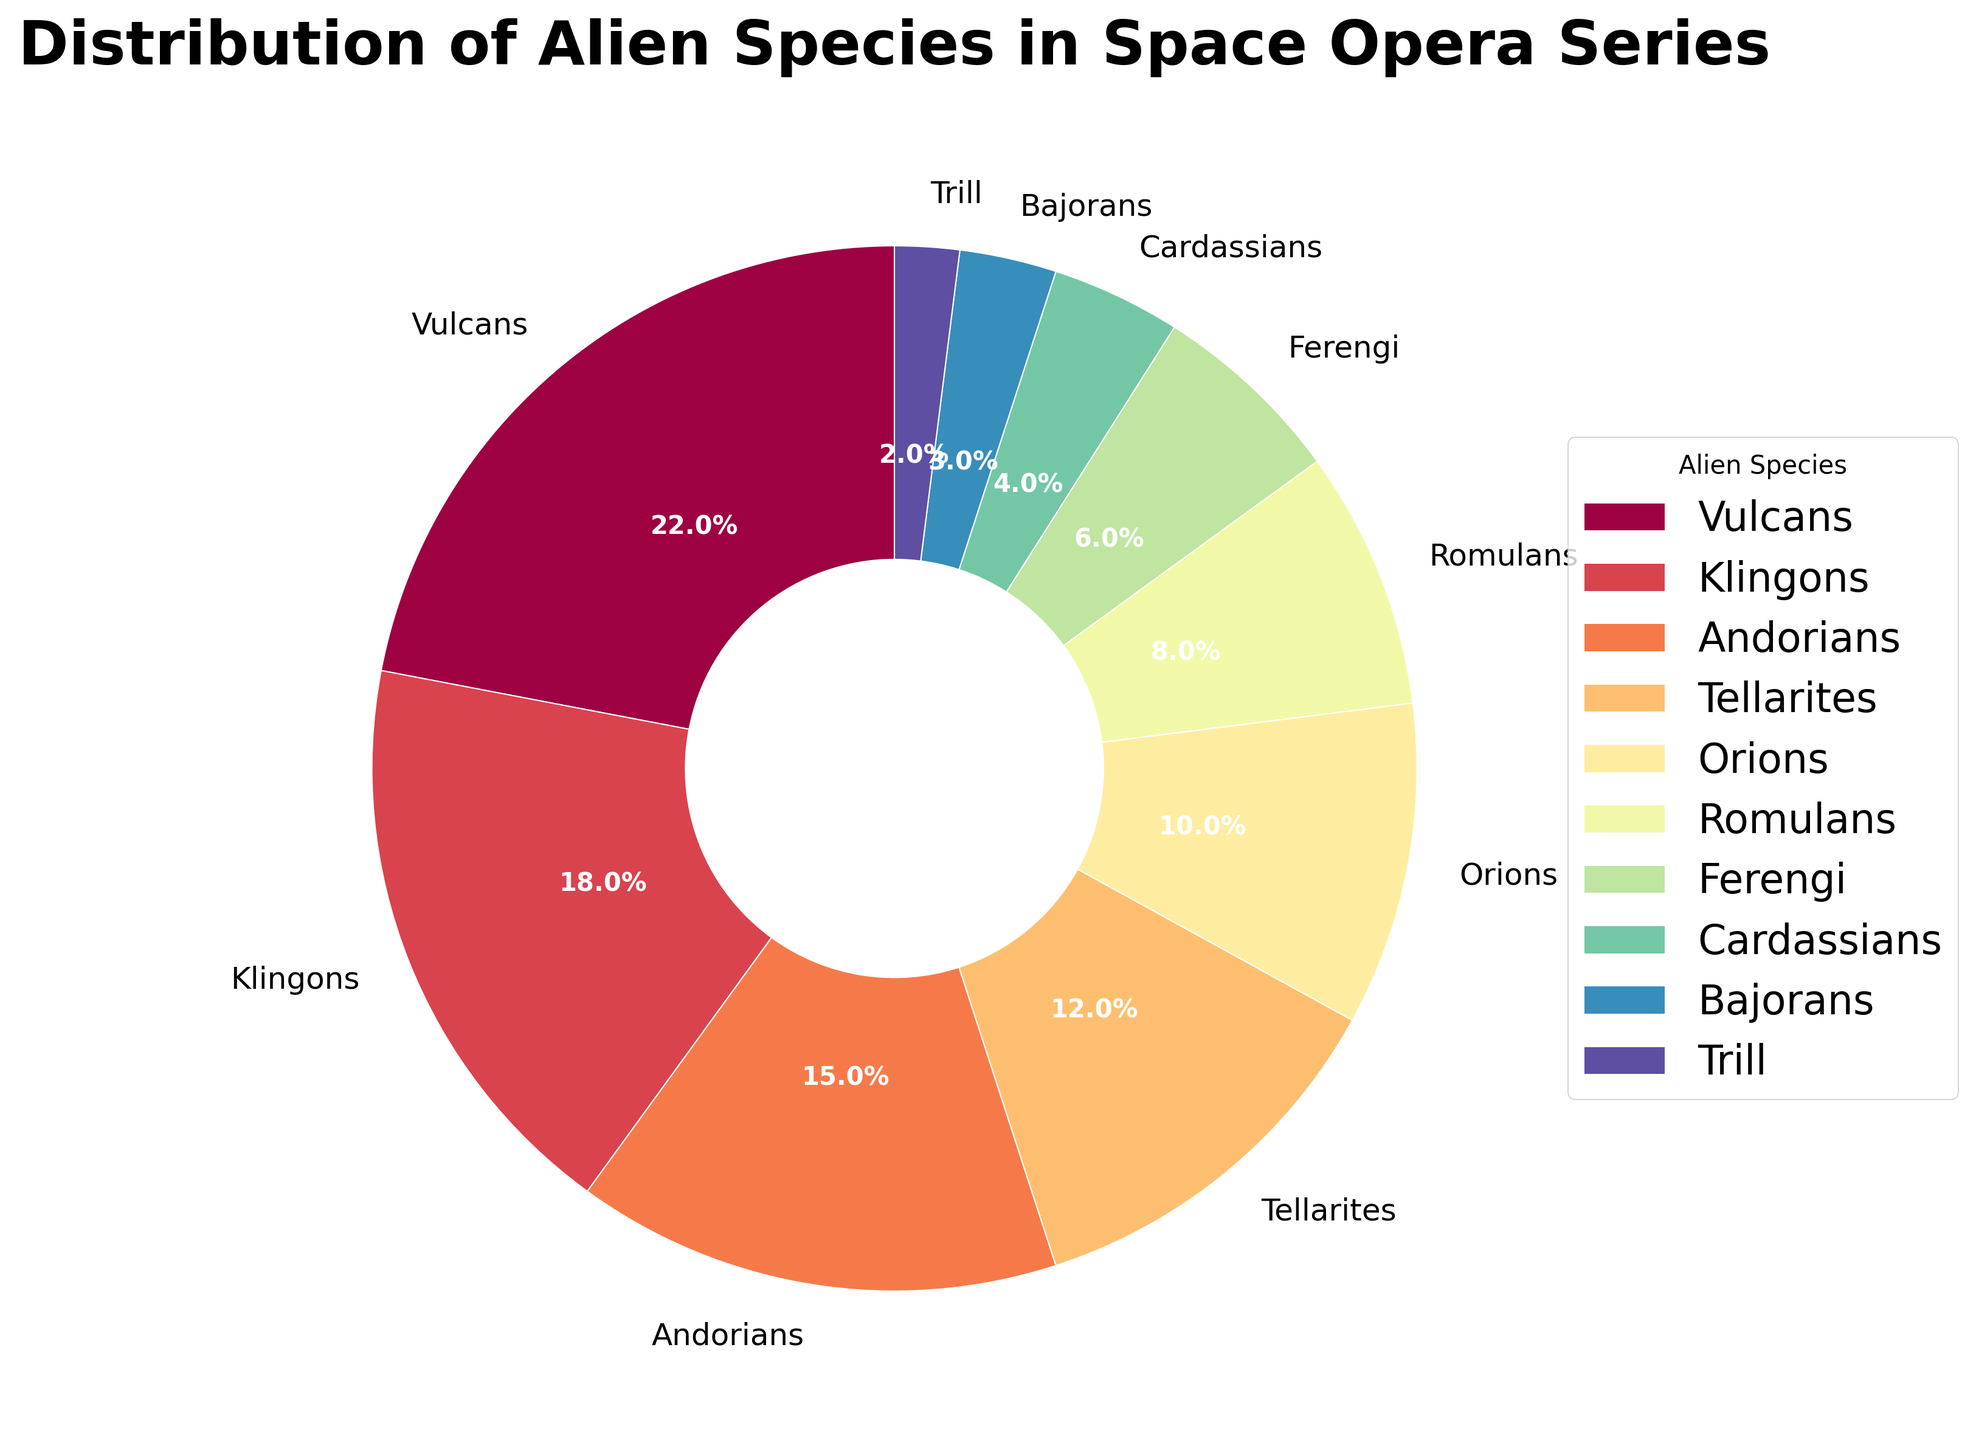Which alien species has the highest percentage in the pie chart? The Vulcans take the largest slice of the pie at 22%, as indicated in the chart.
Answer: Vulcans What is the combined percentage of Andorians and Tellarites? The percentage for Andorians is 15% and for Tellarites is 12%. Adding these together gives 15% + 12% = 27%.
Answer: 27% Compare the percentage of Klingons and Romulans. Which is higher and by how much? Klingons have 18% and Romulans have 8%. The difference between them is 18% - 8% = 10%.
Answer: Klingons by 10% What percentage of the pie chart is represented by Orions and Ferengi together? Orions have 10% and Ferengi have 6%. Summing these percentages gives 10% + 6% = 16%.
Answer: 16% Are there more Ferengi or Cardassians, and by what percentage? Ferengi account for 6% while Cardassians account for 4%. The Ferengi percentage is higher by 6% - 4% = 2%.
Answer: Ferengi by 2% Which species has the smallest representation and what is its percentage? The Trill have the smallest representation with a percentage of 2%.
Answer: Trill, 2% How does the percentage of Bajorans compare to that of the Romulans? Bajorans have a percentage of 3%, while Romulans have 8%. The Romulans have 8% - 3% = 5% more.
Answer: Romulans by 5% What is the total percentage of species that have a representation of less than 10% each? The species with less than 10% each are Romulans (8%), Ferengi (6%), Cardassians (4%), Bajorans (3%), and Trill (2%). Summing these gives 8% + 6% + 4% + 3% + 2% = 23%.
Answer: 23% Which species are represented by more than 15% each, and what are their percentages? The species with more than 15% each are Vulcans (22%) and Klingons (18%).
Answer: Vulcans, 22%; Klingons, 18% 